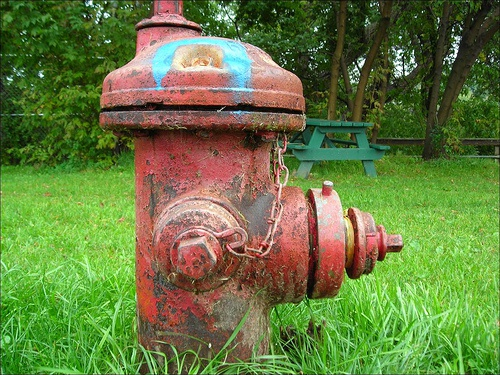Describe the objects in this image and their specific colors. I can see fire hydrant in black, brown, lightpink, maroon, and olive tones, dining table in black and teal tones, and bench in black, teal, and darkgreen tones in this image. 